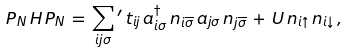Convert formula to latex. <formula><loc_0><loc_0><loc_500><loc_500>P _ { N } \, H \, P _ { N } \, = \, \sum _ { i j \sigma } { ^ { \prime } } \, t _ { i j } \, a _ { i \sigma } ^ { \dagger } \, n _ { i \overline { \sigma } } \, a _ { j \sigma } \, n _ { j \overline { \sigma } } \, + \, U \, n _ { i \uparrow } \, n _ { i \downarrow } \, ,</formula> 